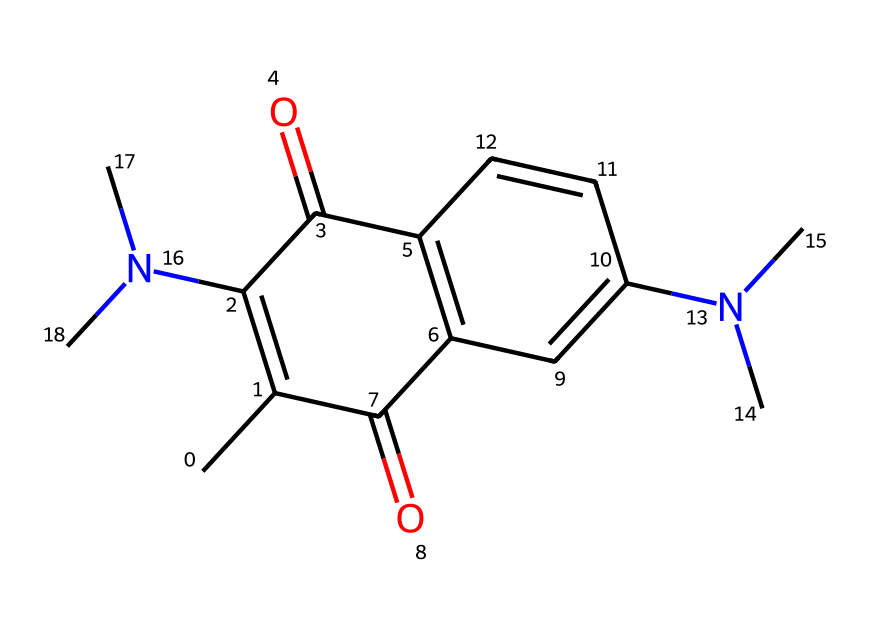how many carbon atoms are in the compound? By examining the SMILES representation, we can count the number of carbon (C) atoms present. In this structure, every "C" represents a carbon atom. There are ten occurrences of "C" in the SMILES notation.
Answer: 10 how many nitrogen atoms are in the compound? In the SMILES notation, "N" represents a nitrogen atom. Counting the occurrences, we find two nitrogen atoms in the structure.
Answer: 2 what is the molecular formula of this compound? To determine the molecular formula, we can tally the numbers of each type of atom from the SMILES representation. The counts are 10 Carbon (C), 12 Hydrogen (H), 2 Nitrogen (N), and 2 Oxygen (O), giving a molecular formula of C10H12N2O2.
Answer: C10H12N2O2 which functional groups are present in this compound? Analyzing the structure, we can identify several functional groups based on common structures. The presence of carbonyl groups (C=O) indicates the presence of keto groups, and nitrogen atoms suggest amines. Therefore, we can conclude it has keto and amine functional groups.
Answer: keto, amine what type of light-reactive characteristics might this compound possess? The compound contains both conjugated double bonds and carbonyl (C=O) groups, which are often found in compounds that exhibit light-reactive properties due to their ability to enter excited states upon light absorption. Hence, it may possess photoreactive characteristics suitable for photoresists.
Answer: photoreactive describe the role of nitrogen in the structure. The nitrogen atoms present in the chemical structure impart basicity and can influence the reactivity and interaction of the molecule with light, as they can participate in resonance and stabilization of excited states, making them crucial for the function of photoresists.
Answer: stabilization what might be the significance of this compound in the context of photoresists? This compound's structure, notably its light-reactive components and ability to undergo changes upon exposure to light, makes it highly suitable as a photoresist, which is essential in photolithography processes used in semiconductor manufacturing.
Answer: essential in photolithography 